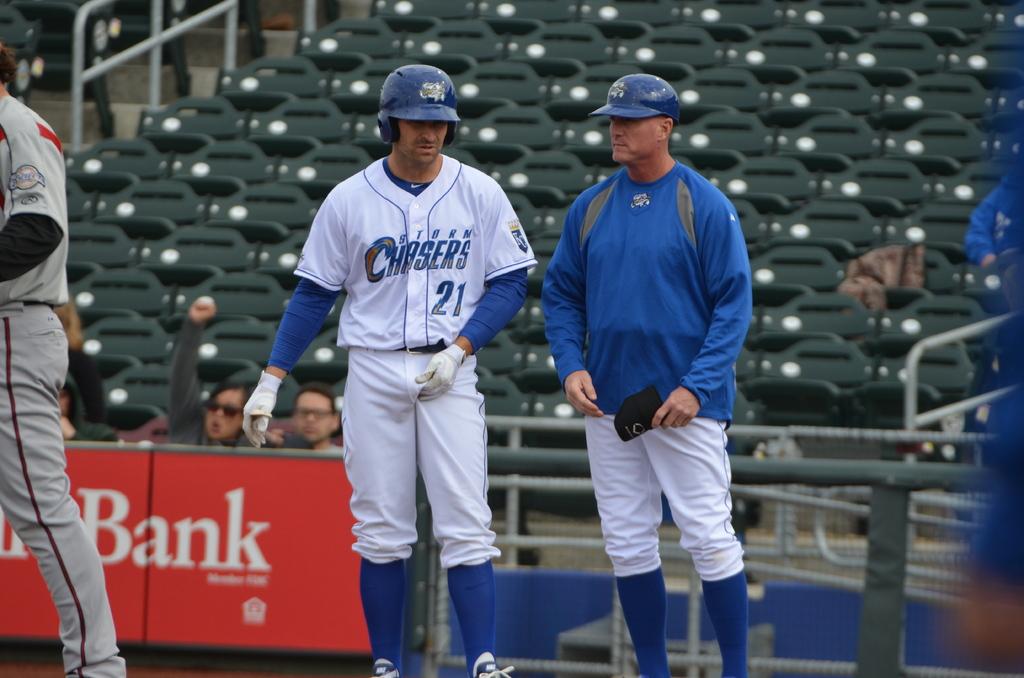Is he on the chasers?
Offer a very short reply. Yes. Is that a bank sponsor in the background?
Offer a terse response. Yes. 